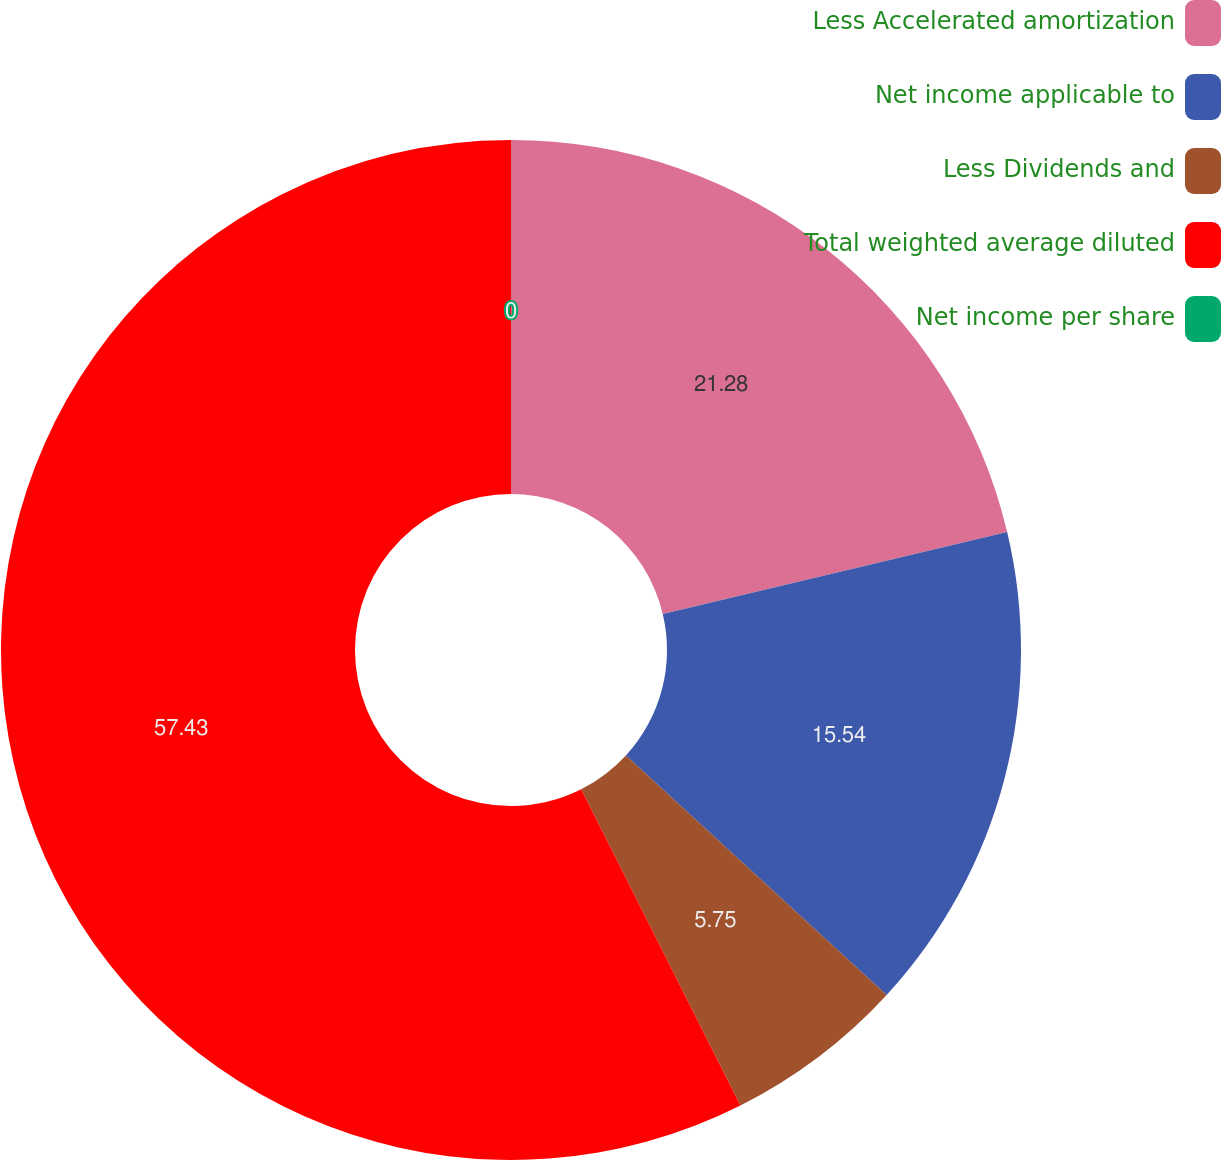Convert chart. <chart><loc_0><loc_0><loc_500><loc_500><pie_chart><fcel>Less Accelerated amortization<fcel>Net income applicable to<fcel>Less Dividends and<fcel>Total weighted average diluted<fcel>Net income per share<nl><fcel>21.28%<fcel>15.54%<fcel>5.75%<fcel>57.42%<fcel>0.0%<nl></chart> 